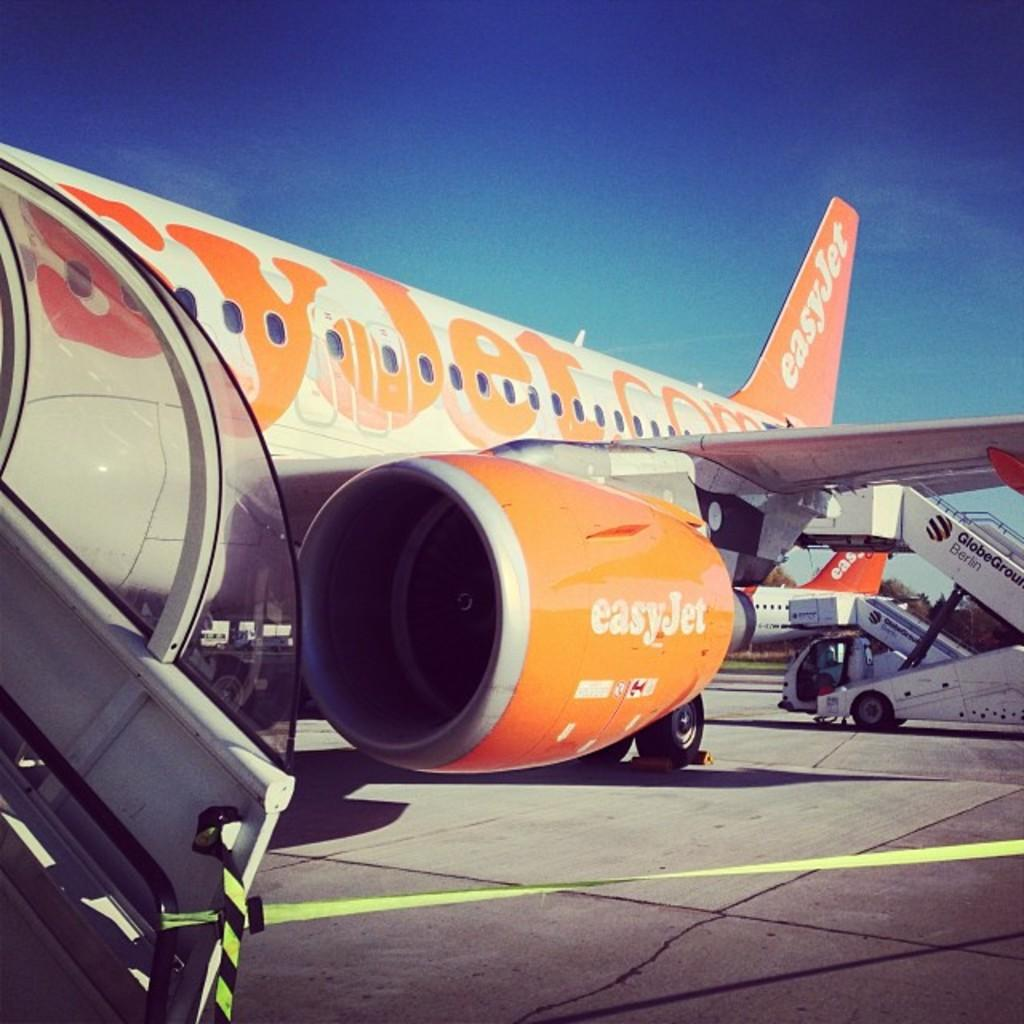<image>
Write a terse but informative summary of the picture. An EasyJet airplane is painted white and bright orange. 